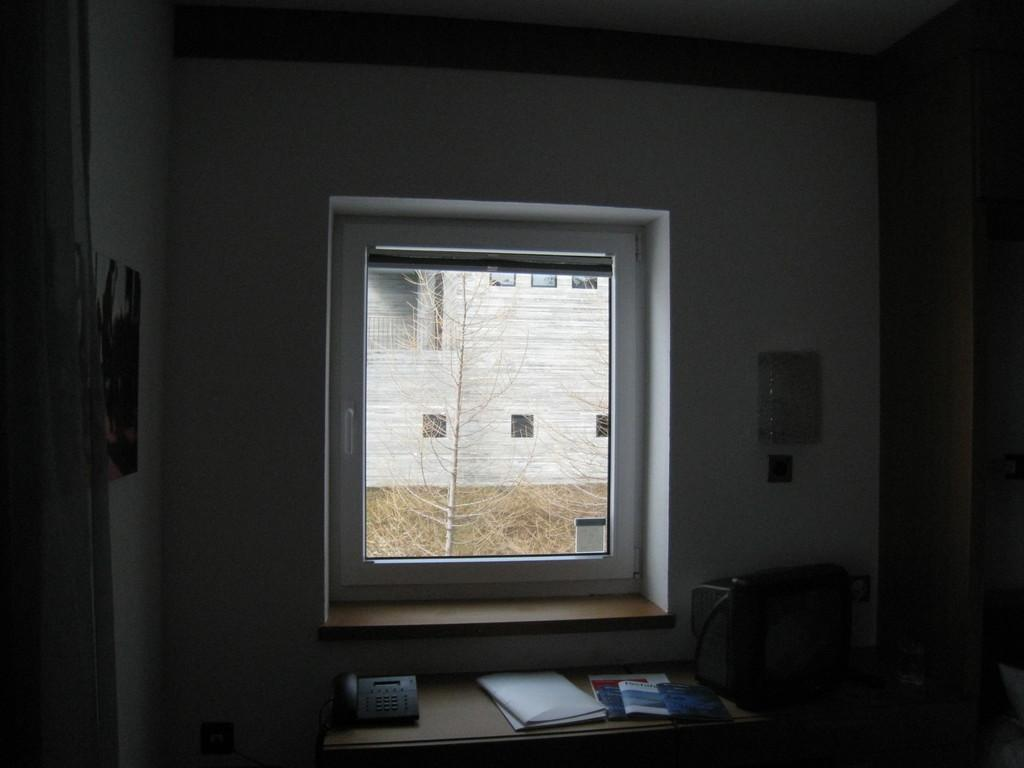What is located in the center of the image? There is a window in the center of the image. What is at the bottom of the image? There is a table at the bottom of the image. What can be found on the table? A telephone and papers are present on the table. What is visible in the background of the image? There is a building and a tree visible in the background of the image. How many letters are being delivered by the boat in the image? There is no boat present in the image, so no letters are being delivered. What color is the sock on the tree in the image? There is no sock present in the image, so we cannot determine its color. 